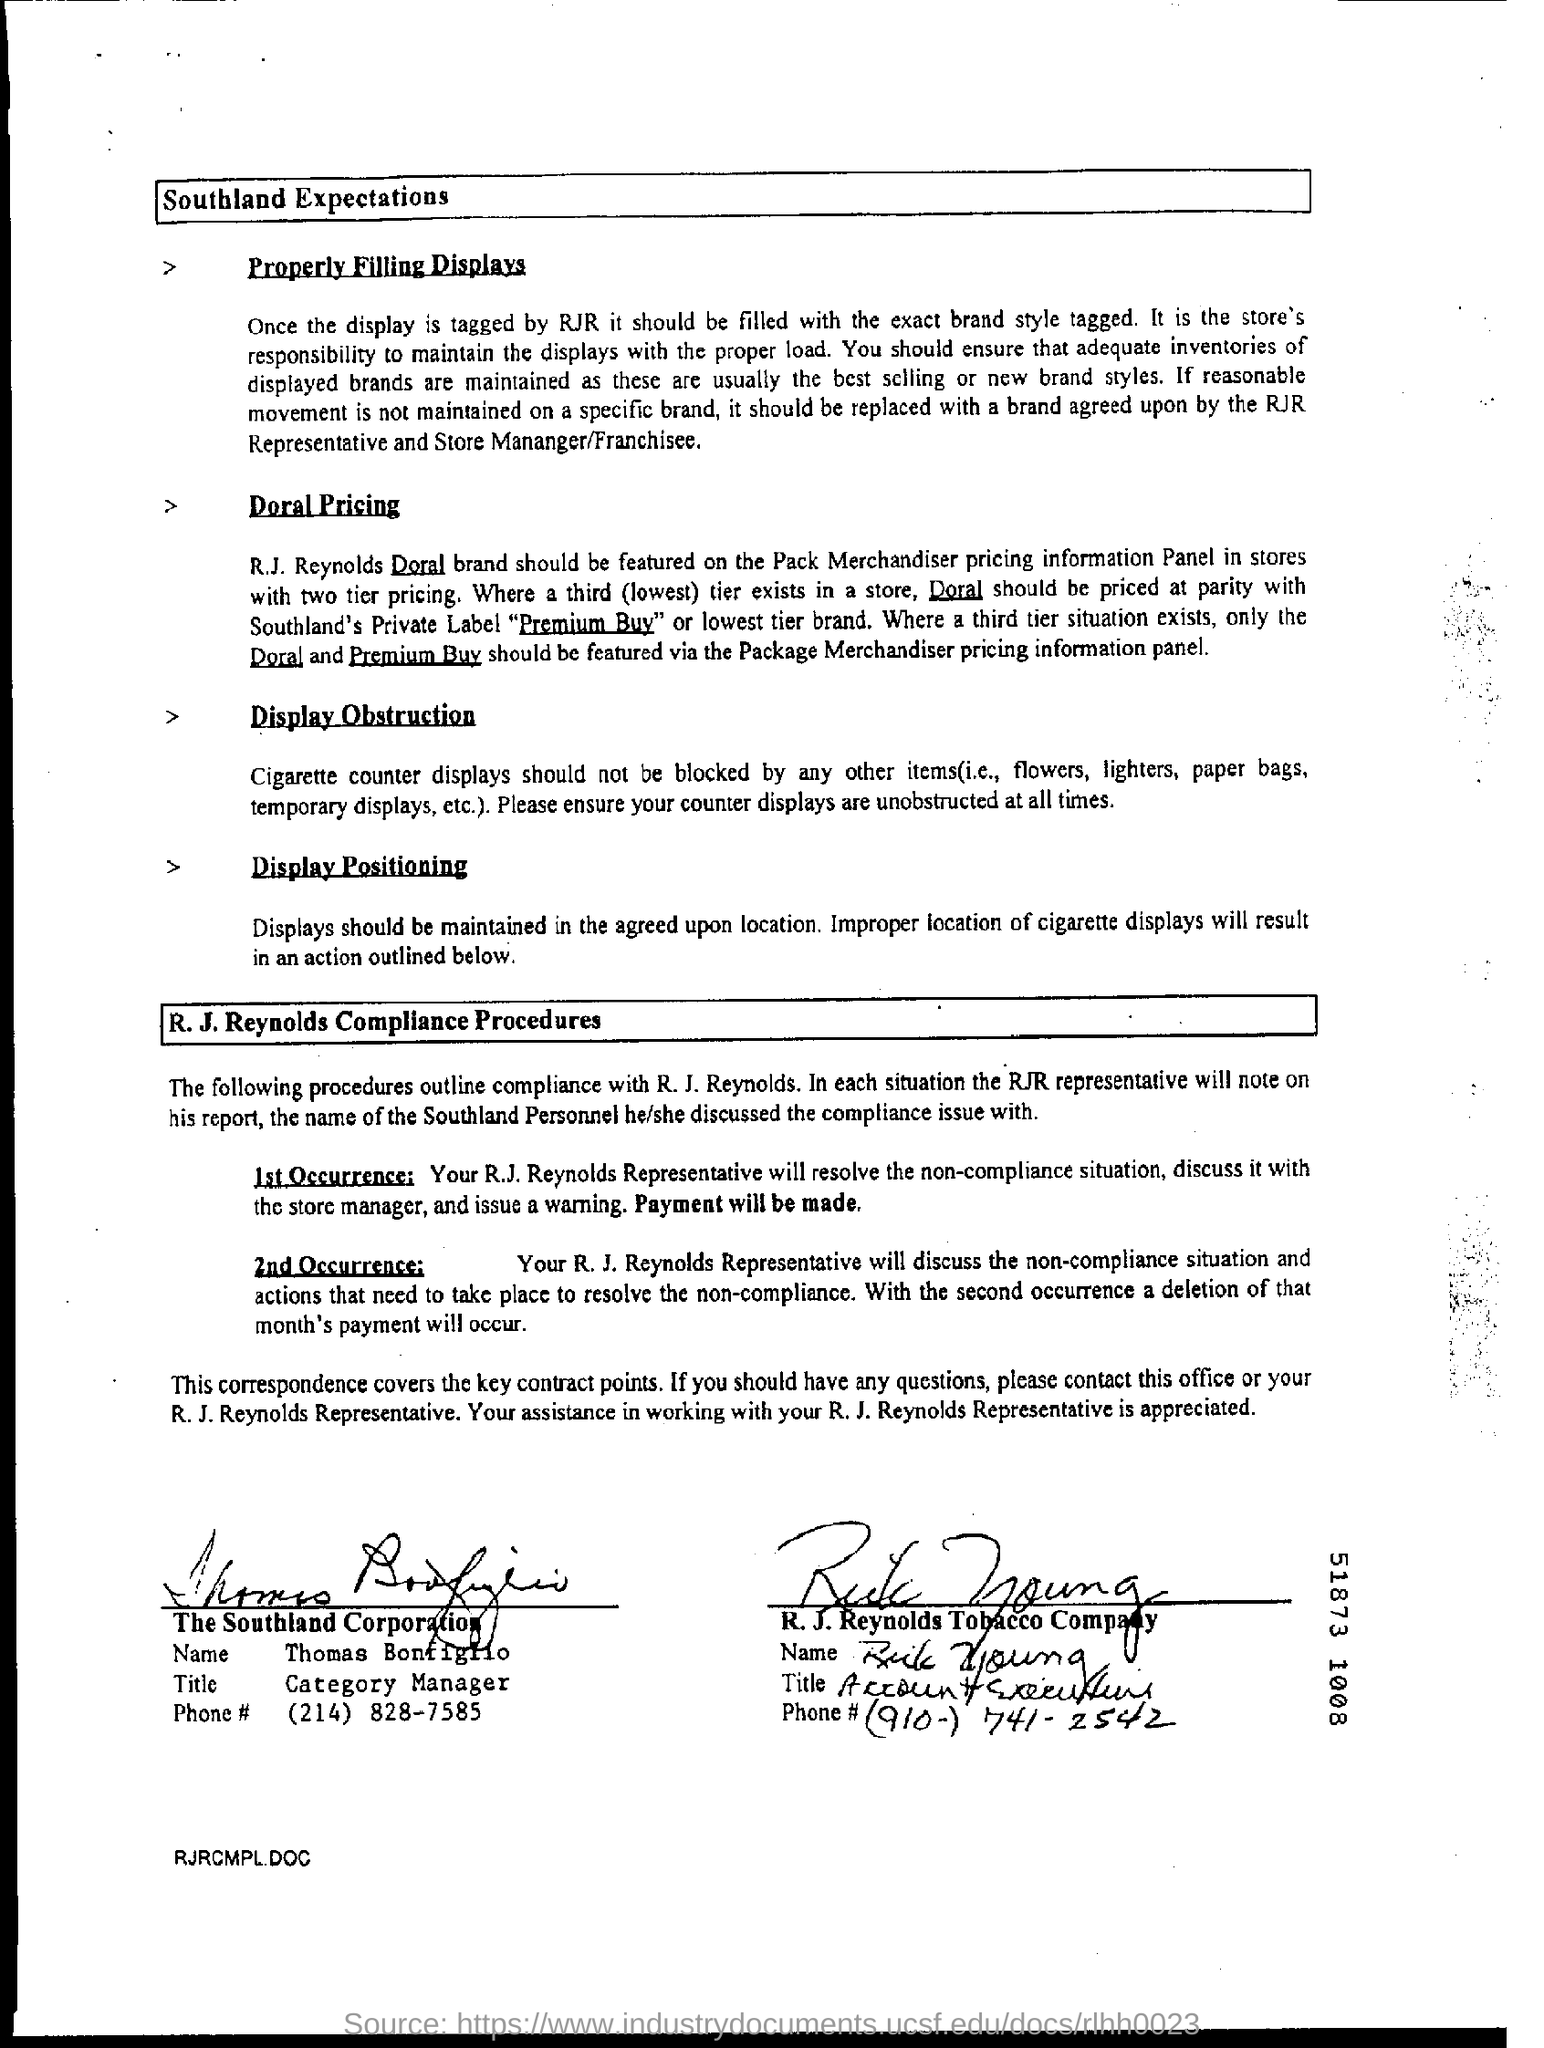What is the title of thomas bonfiglio?
Provide a succinct answer. Category Manager. 